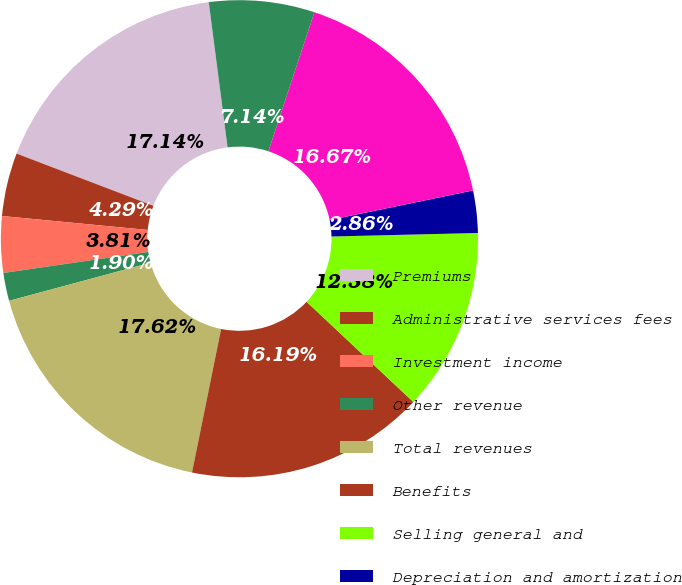Convert chart to OTSL. <chart><loc_0><loc_0><loc_500><loc_500><pie_chart><fcel>Premiums<fcel>Administrative services fees<fcel>Investment income<fcel>Other revenue<fcel>Total revenues<fcel>Benefits<fcel>Selling general and<fcel>Depreciation and amortization<fcel>Total operating expenses<fcel>Income from operations<nl><fcel>17.14%<fcel>4.29%<fcel>3.81%<fcel>1.9%<fcel>17.62%<fcel>16.19%<fcel>12.38%<fcel>2.86%<fcel>16.67%<fcel>7.14%<nl></chart> 